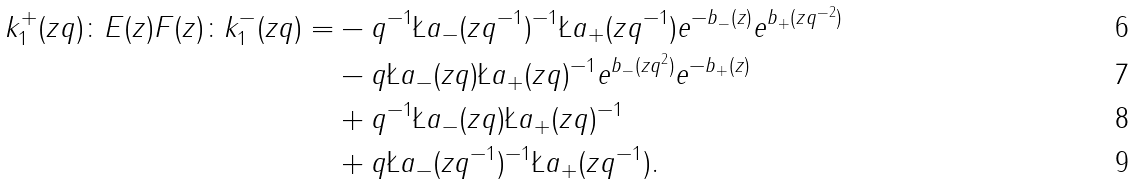Convert formula to latex. <formula><loc_0><loc_0><loc_500><loc_500>k ^ { + } _ { 1 } ( z q ) \colon E ( z ) F ( z ) \colon k ^ { - } _ { 1 } ( z q ) = & - q ^ { - 1 } \L a _ { - } ( z q ^ { - 1 } ) ^ { - 1 } \L a _ { + } ( z q ^ { - 1 } ) e ^ { - b _ { - } ( z ) } e ^ { b _ { + } ( z q ^ { - 2 } ) } \\ & - q \L a _ { - } ( z q ) \L a _ { + } ( z q ) ^ { - 1 } e ^ { b _ { - } ( z q ^ { 2 } ) } e ^ { - b _ { + } ( z ) } \\ & + q ^ { - 1 } \L a _ { - } ( z q ) \L a _ { + } ( z q ) ^ { - 1 } \\ & + q \L a _ { - } ( z q ^ { - 1 } ) ^ { - 1 } \L a _ { + } ( z q ^ { - 1 } ) .</formula> 